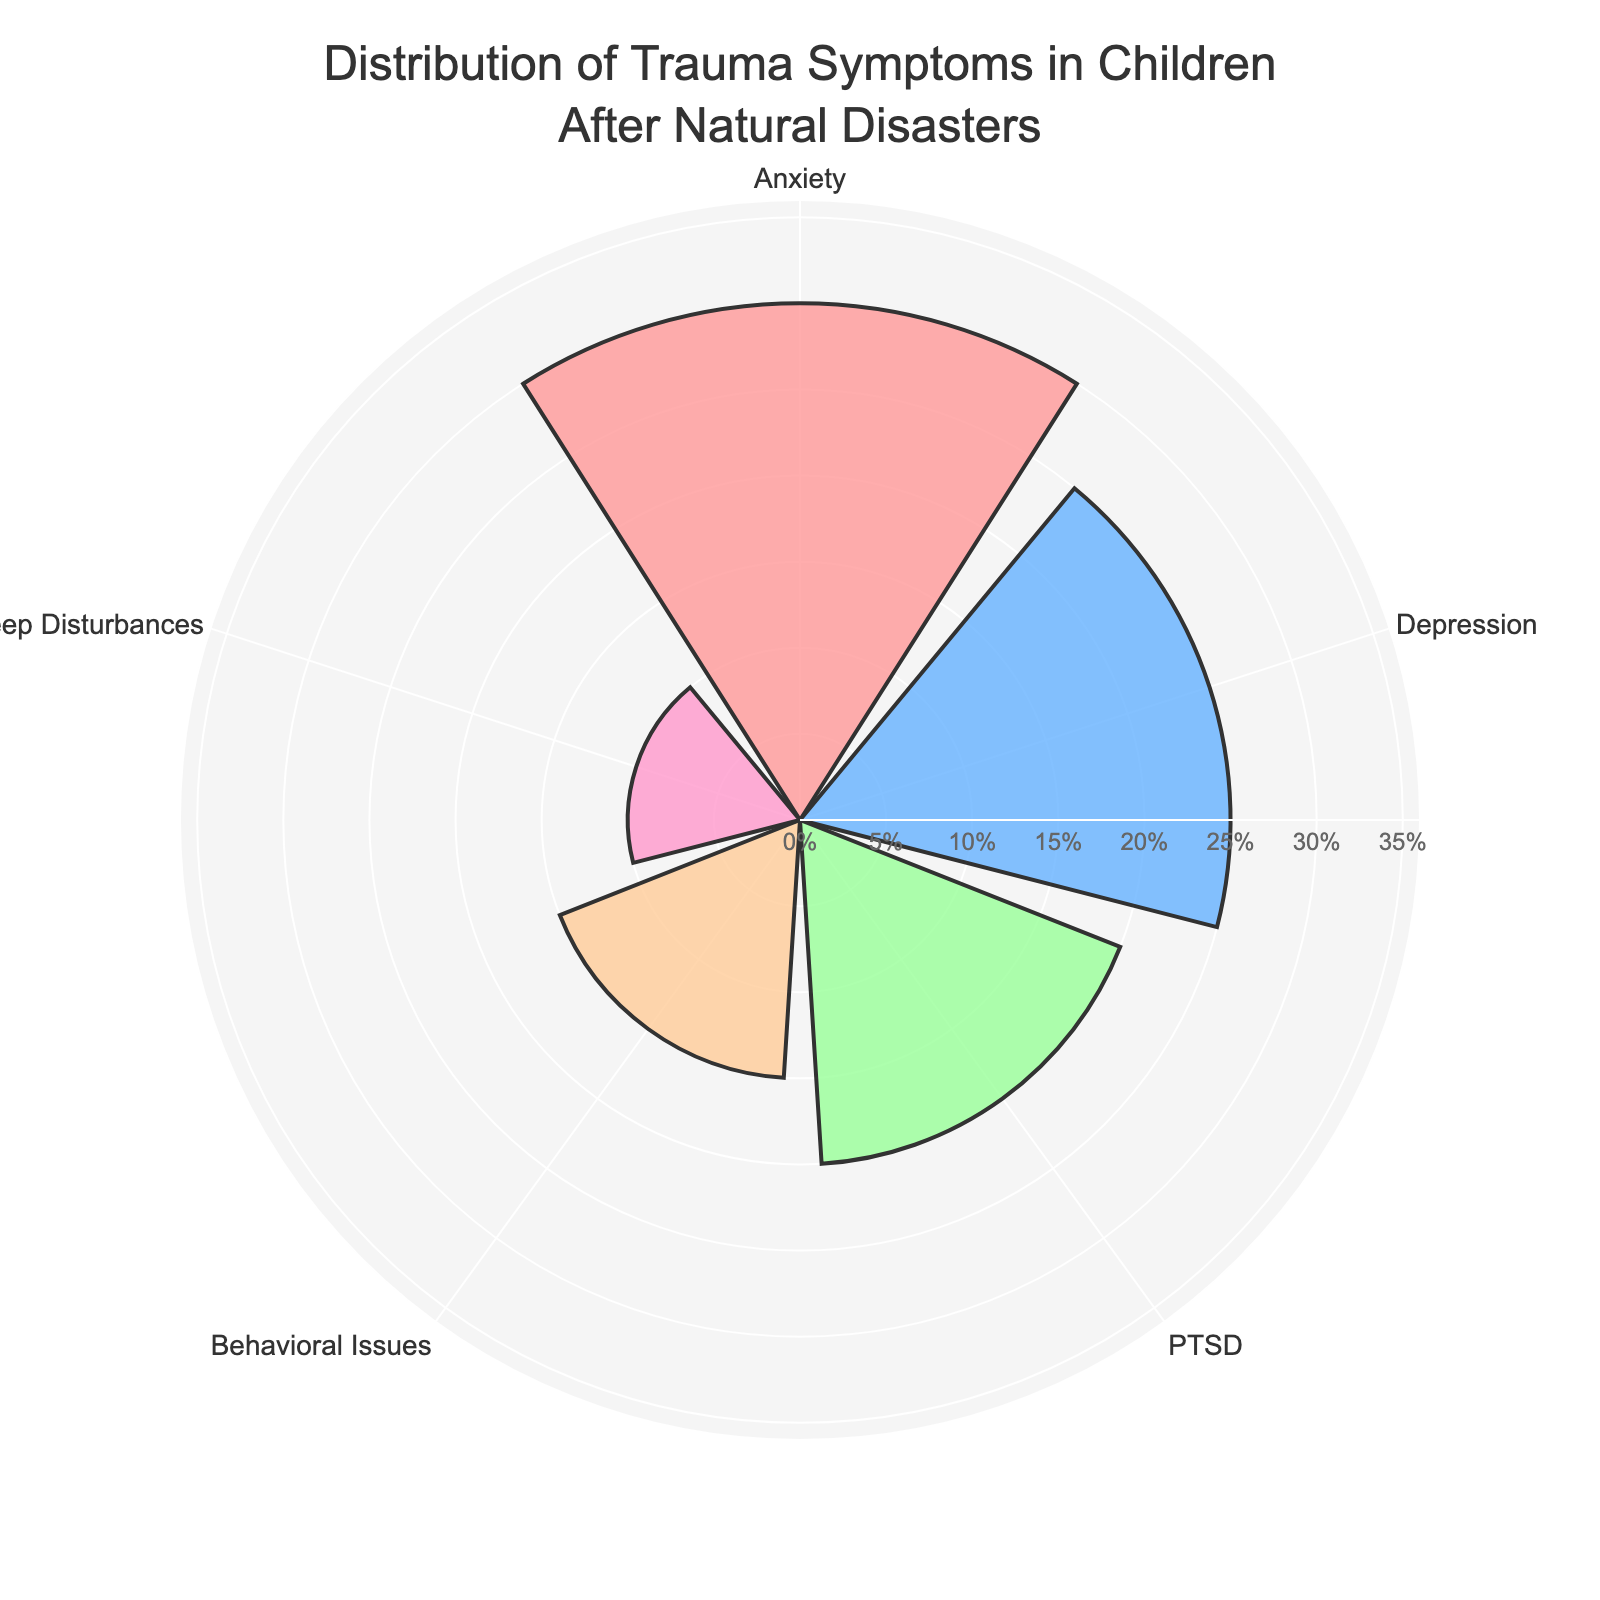How many types of trauma symptoms are presented in the figure? The figure shows different categories, each representing a type of trauma symptom. By counting these categories, we see there are five distinct types: Anxiety, Depression, PTSD, Behavioral Issues, and Sleep Disturbances.
Answer: Five What is the title of the figure? The title of a figure is typically displayed at the top and provides information about the data being visualized. The title in this figure is "Distribution of Trauma Symptoms in Children After Natural Disasters".
Answer: Distribution of Trauma Symptoms in Children After Natural Disasters Which trauma symptom has the highest percentage? By observing the lengths of the bars, we can determine the symptom with the highest value. The bar representing Anxiety extends the furthest, indicating it has the highest percentage at 30%.
Answer: Anxiety What are the color representations for Anxiety and PTSD? Colors are used to differentiate categories. Anxiety is represented by a light pinkish-red color, while PTSD is represented by a green color.
Answer: Light pinkish-red for Anxiety and green for PTSD Which symptom shows the smallest percentage? By looking at the shortest bar in the chart, we can see that Sleep Disturbances has the smallest percentage at 10%.
Answer: Sleep Disturbances What is the combined percentage of Depression and PTSD? To find the combined percentage, we add the percentages for Depression and PTSD: 25% (Depression) + 20% (PTSD) = 45%.
Answer: 45% How much greater is the percentage of Anxiety compared to Behavioral Issues? We subtract the percentage of Behavioral Issues from Anxiety: 30% (Anxiety) - 15% (Behavioral Issues) = 15%.
Answer: 15% Which symptom has the second highest percentage? The second longest bar represents Depression at 25%, showing it has the second highest percentage.
Answer: Depression What is the average percentage of all trauma symptoms shown? To find the average, sum all percentages and divide by the number of categories. (30 + 25 + 20 + 15 + 10) / 5 = 20%
Answer: 20% If you combine the percentages of Behavioral Issues and Sleep Disturbances, would it be greater than the percentage of Depression? Adding the percentages of Behavioral Issues and Sleep Disturbances gives 15% + 10% = 25%. This is equal to the percentage of Depression, not greater.
Answer: No, it is equal 